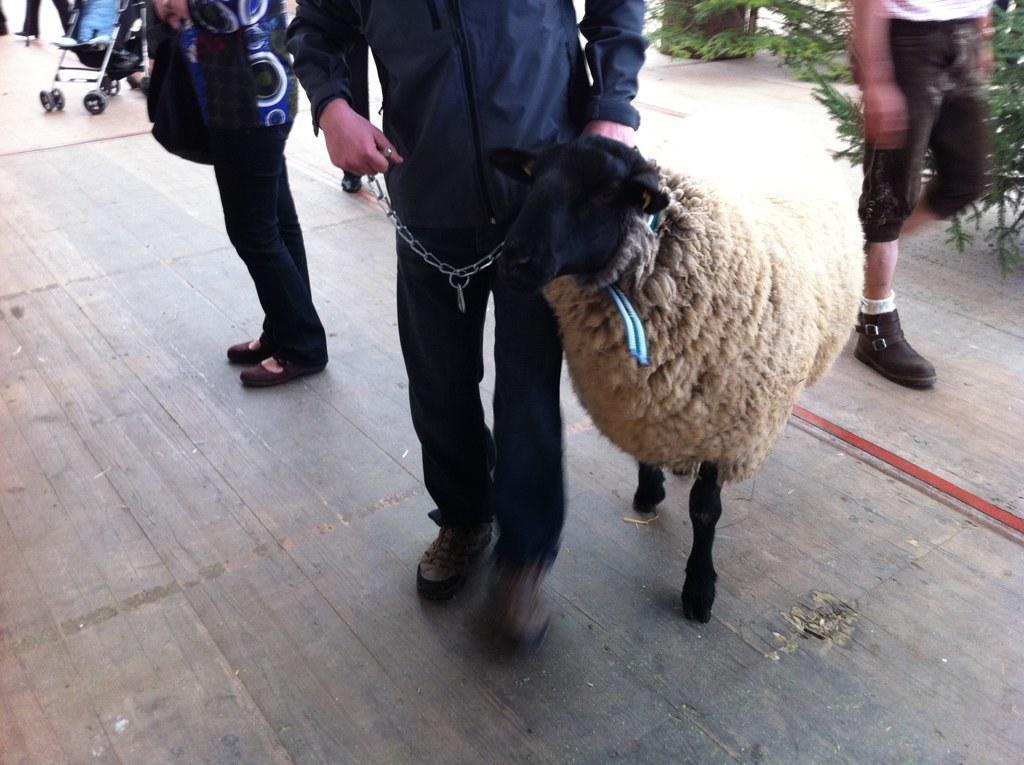Describe this image in one or two sentences. In the center of the image a man is holding a sheep. In the background of the image we can see some persons, plant are there. At the top left corner trolley is there. At the bottom of the image ground is there. 